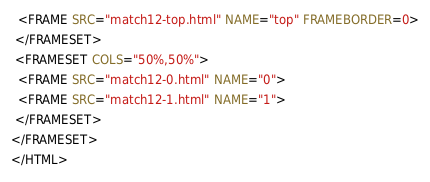Convert code to text. <code><loc_0><loc_0><loc_500><loc_500><_HTML_>  <FRAME SRC="match12-top.html" NAME="top" FRAMEBORDER=0>
 </FRAMESET>
 <FRAMESET COLS="50%,50%">
  <FRAME SRC="match12-0.html" NAME="0">
  <FRAME SRC="match12-1.html" NAME="1">
 </FRAMESET>
</FRAMESET>
</HTML>
</code> 